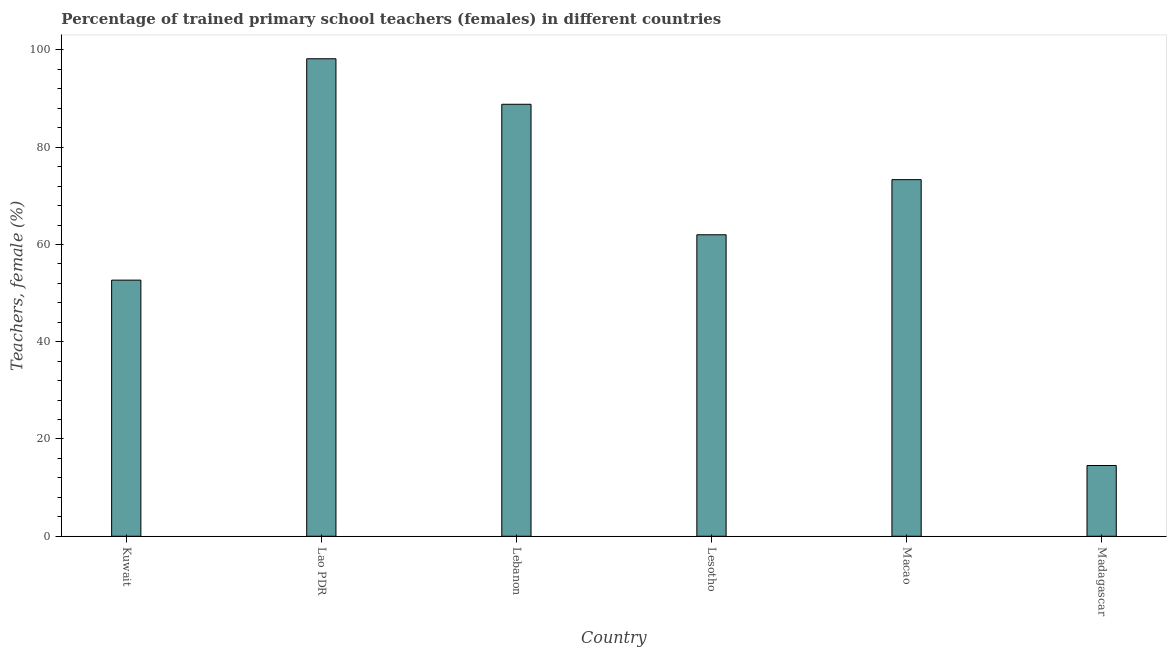Does the graph contain any zero values?
Your response must be concise. No. Does the graph contain grids?
Your response must be concise. No. What is the title of the graph?
Your response must be concise. Percentage of trained primary school teachers (females) in different countries. What is the label or title of the X-axis?
Your response must be concise. Country. What is the label or title of the Y-axis?
Ensure brevity in your answer.  Teachers, female (%). What is the percentage of trained female teachers in Macao?
Your response must be concise. 73.33. Across all countries, what is the maximum percentage of trained female teachers?
Provide a short and direct response. 98.19. Across all countries, what is the minimum percentage of trained female teachers?
Make the answer very short. 14.55. In which country was the percentage of trained female teachers maximum?
Your response must be concise. Lao PDR. In which country was the percentage of trained female teachers minimum?
Provide a succinct answer. Madagascar. What is the sum of the percentage of trained female teachers?
Your answer should be very brief. 389.57. What is the difference between the percentage of trained female teachers in Lao PDR and Lesotho?
Provide a succinct answer. 36.2. What is the average percentage of trained female teachers per country?
Offer a very short reply. 64.93. What is the median percentage of trained female teachers?
Your response must be concise. 67.67. What is the ratio of the percentage of trained female teachers in Kuwait to that in Macao?
Your response must be concise. 0.72. What is the difference between the highest and the second highest percentage of trained female teachers?
Offer a terse response. 9.36. What is the difference between the highest and the lowest percentage of trained female teachers?
Keep it short and to the point. 83.65. In how many countries, is the percentage of trained female teachers greater than the average percentage of trained female teachers taken over all countries?
Give a very brief answer. 3. Are all the bars in the graph horizontal?
Provide a succinct answer. No. What is the difference between two consecutive major ticks on the Y-axis?
Provide a succinct answer. 20. What is the Teachers, female (%) in Kuwait?
Give a very brief answer. 52.67. What is the Teachers, female (%) of Lao PDR?
Your answer should be very brief. 98.19. What is the Teachers, female (%) of Lebanon?
Ensure brevity in your answer.  88.83. What is the Teachers, female (%) in Lesotho?
Your response must be concise. 62. What is the Teachers, female (%) in Macao?
Your answer should be very brief. 73.33. What is the Teachers, female (%) of Madagascar?
Provide a succinct answer. 14.55. What is the difference between the Teachers, female (%) in Kuwait and Lao PDR?
Keep it short and to the point. -45.53. What is the difference between the Teachers, female (%) in Kuwait and Lebanon?
Make the answer very short. -36.16. What is the difference between the Teachers, female (%) in Kuwait and Lesotho?
Your response must be concise. -9.33. What is the difference between the Teachers, female (%) in Kuwait and Macao?
Provide a succinct answer. -20.66. What is the difference between the Teachers, female (%) in Kuwait and Madagascar?
Provide a succinct answer. 38.12. What is the difference between the Teachers, female (%) in Lao PDR and Lebanon?
Ensure brevity in your answer.  9.36. What is the difference between the Teachers, female (%) in Lao PDR and Lesotho?
Offer a very short reply. 36.2. What is the difference between the Teachers, female (%) in Lao PDR and Macao?
Offer a very short reply. 24.86. What is the difference between the Teachers, female (%) in Lao PDR and Madagascar?
Offer a terse response. 83.65. What is the difference between the Teachers, female (%) in Lebanon and Lesotho?
Offer a very short reply. 26.83. What is the difference between the Teachers, female (%) in Lebanon and Macao?
Ensure brevity in your answer.  15.5. What is the difference between the Teachers, female (%) in Lebanon and Madagascar?
Your response must be concise. 74.29. What is the difference between the Teachers, female (%) in Lesotho and Macao?
Give a very brief answer. -11.34. What is the difference between the Teachers, female (%) in Lesotho and Madagascar?
Your answer should be compact. 47.45. What is the difference between the Teachers, female (%) in Macao and Madagascar?
Your answer should be very brief. 58.79. What is the ratio of the Teachers, female (%) in Kuwait to that in Lao PDR?
Offer a very short reply. 0.54. What is the ratio of the Teachers, female (%) in Kuwait to that in Lebanon?
Your response must be concise. 0.59. What is the ratio of the Teachers, female (%) in Kuwait to that in Macao?
Ensure brevity in your answer.  0.72. What is the ratio of the Teachers, female (%) in Kuwait to that in Madagascar?
Ensure brevity in your answer.  3.62. What is the ratio of the Teachers, female (%) in Lao PDR to that in Lebanon?
Provide a short and direct response. 1.1. What is the ratio of the Teachers, female (%) in Lao PDR to that in Lesotho?
Offer a very short reply. 1.58. What is the ratio of the Teachers, female (%) in Lao PDR to that in Macao?
Give a very brief answer. 1.34. What is the ratio of the Teachers, female (%) in Lao PDR to that in Madagascar?
Your response must be concise. 6.75. What is the ratio of the Teachers, female (%) in Lebanon to that in Lesotho?
Your answer should be compact. 1.43. What is the ratio of the Teachers, female (%) in Lebanon to that in Macao?
Your answer should be very brief. 1.21. What is the ratio of the Teachers, female (%) in Lebanon to that in Madagascar?
Provide a succinct answer. 6.11. What is the ratio of the Teachers, female (%) in Lesotho to that in Macao?
Give a very brief answer. 0.84. What is the ratio of the Teachers, female (%) in Lesotho to that in Madagascar?
Provide a succinct answer. 4.26. What is the ratio of the Teachers, female (%) in Macao to that in Madagascar?
Your answer should be very brief. 5.04. 